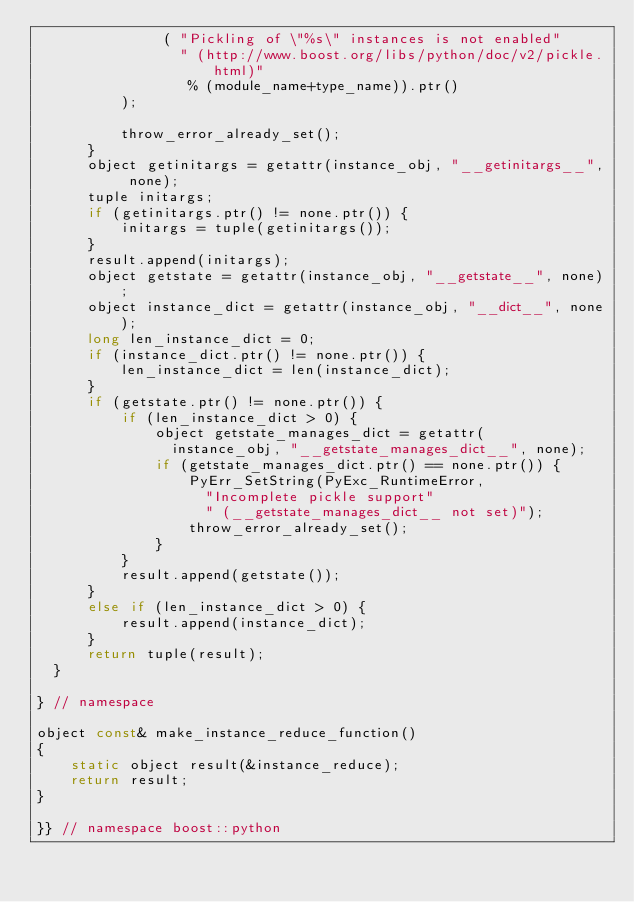<code> <loc_0><loc_0><loc_500><loc_500><_C++_>               ( "Pickling of \"%s\" instances is not enabled"
                 " (http://www.boost.org/libs/python/doc/v2/pickle.html)"
                  % (module_name+type_name)).ptr()
          );

          throw_error_already_set();
      }
      object getinitargs = getattr(instance_obj, "__getinitargs__", none);
      tuple initargs;
      if (getinitargs.ptr() != none.ptr()) {
          initargs = tuple(getinitargs());
      }
      result.append(initargs);
      object getstate = getattr(instance_obj, "__getstate__", none);
      object instance_dict = getattr(instance_obj, "__dict__", none);
      long len_instance_dict = 0;
      if (instance_dict.ptr() != none.ptr()) {
          len_instance_dict = len(instance_dict);
      }
      if (getstate.ptr() != none.ptr()) {
          if (len_instance_dict > 0) {
              object getstate_manages_dict = getattr(
                instance_obj, "__getstate_manages_dict__", none);
              if (getstate_manages_dict.ptr() == none.ptr()) {
                  PyErr_SetString(PyExc_RuntimeError,
                    "Incomplete pickle support"
                    " (__getstate_manages_dict__ not set)");
                  throw_error_already_set();
              }
          }
          result.append(getstate());
      }
      else if (len_instance_dict > 0) {
          result.append(instance_dict);
      }
      return tuple(result);
  }

} // namespace

object const& make_instance_reduce_function()
{
    static object result(&instance_reduce);
    return result;
}

}} // namespace boost::python
</code> 